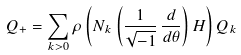Convert formula to latex. <formula><loc_0><loc_0><loc_500><loc_500>Q _ { + } = \sum _ { k > 0 } \rho \left ( N _ { k } \left ( \frac { 1 } { \sqrt { - 1 } } \, \frac { d } { d \theta } \right ) H \right ) Q _ { k }</formula> 